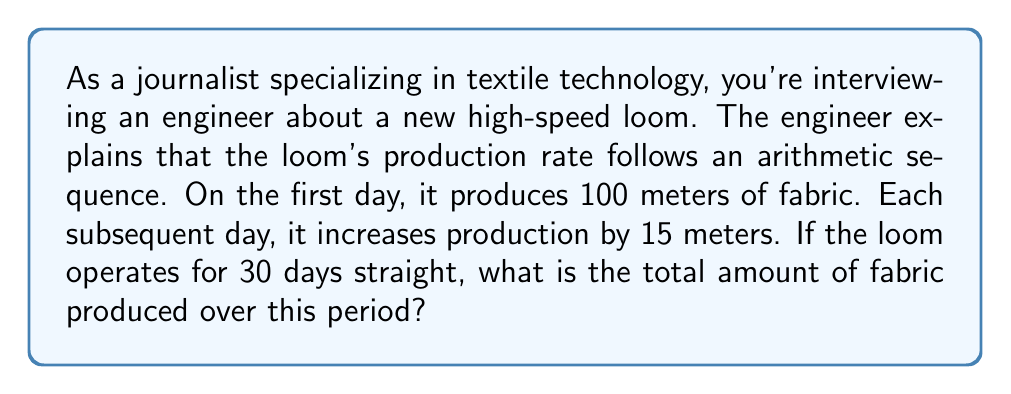Show me your answer to this math problem. To solve this problem, we need to use the formula for the sum of an arithmetic sequence:

$$ S_n = \frac{n(a_1 + a_n)}{2} $$

Where:
$S_n$ is the sum of the sequence
$n$ is the number of terms
$a_1$ is the first term
$a_n$ is the last term

We know:
$n = 30$ (days)
$a_1 = 100$ (meters on the first day)
The common difference $d = 15$ (meters increase per day)

To find $a_n$, we use the arithmetic sequence formula:
$$ a_n = a_1 + (n-1)d $$
$$ a_{30} = 100 + (30-1)15 = 100 + 435 = 535 $$

Now we can plug these values into our sum formula:

$$ S_{30} = \frac{30(100 + 535)}{2} $$
$$ S_{30} = \frac{30(635)}{2} $$
$$ S_{30} = \frac{19050}{2} = 9525 $$

Therefore, the total amount of fabric produced over 30 days is 9,525 meters.
Answer: 9,525 meters 